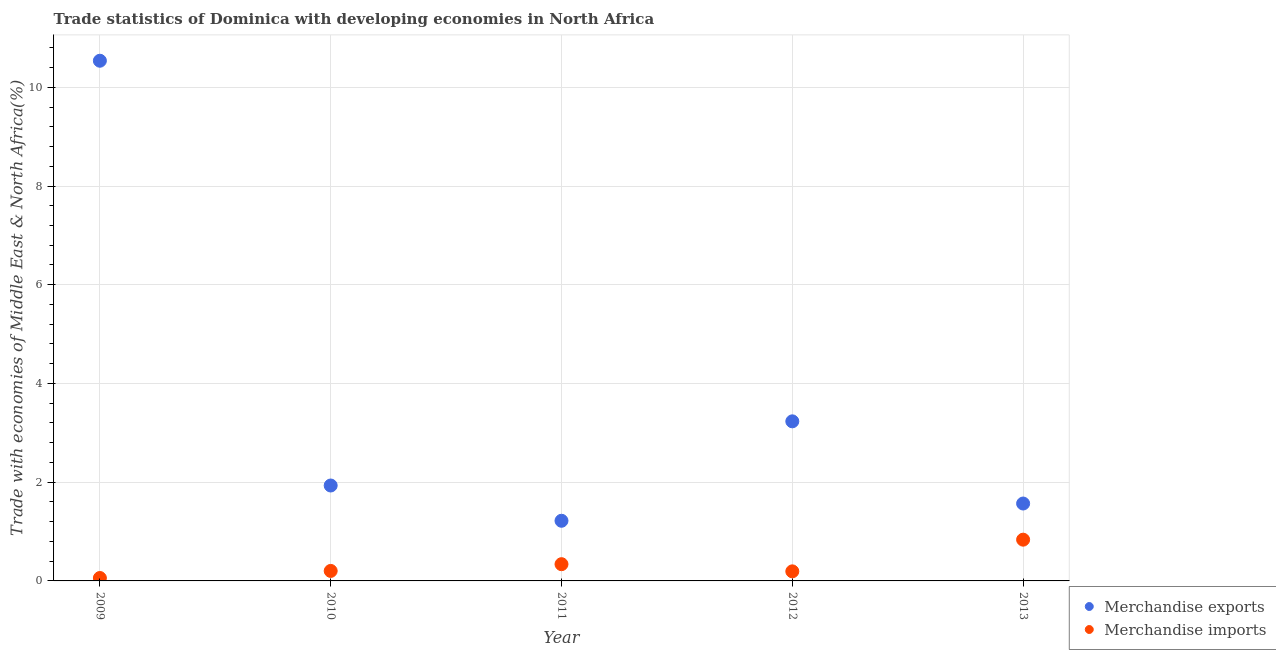What is the merchandise exports in 2012?
Give a very brief answer. 3.23. Across all years, what is the maximum merchandise imports?
Ensure brevity in your answer.  0.84. Across all years, what is the minimum merchandise imports?
Your answer should be very brief. 0.06. In which year was the merchandise imports maximum?
Offer a very short reply. 2013. What is the total merchandise exports in the graph?
Keep it short and to the point. 18.49. What is the difference between the merchandise exports in 2009 and that in 2011?
Give a very brief answer. 9.32. What is the difference between the merchandise exports in 2011 and the merchandise imports in 2013?
Your answer should be very brief. 0.38. What is the average merchandise exports per year?
Make the answer very short. 3.7. In the year 2011, what is the difference between the merchandise exports and merchandise imports?
Your answer should be compact. 0.88. In how many years, is the merchandise exports greater than 6.4 %?
Give a very brief answer. 1. What is the ratio of the merchandise imports in 2011 to that in 2013?
Your response must be concise. 0.41. Is the difference between the merchandise imports in 2010 and 2011 greater than the difference between the merchandise exports in 2010 and 2011?
Make the answer very short. No. What is the difference between the highest and the second highest merchandise imports?
Your answer should be very brief. 0.5. What is the difference between the highest and the lowest merchandise exports?
Provide a succinct answer. 9.32. Is the sum of the merchandise imports in 2010 and 2012 greater than the maximum merchandise exports across all years?
Offer a very short reply. No. Does the merchandise imports monotonically increase over the years?
Offer a very short reply. No. Is the merchandise imports strictly greater than the merchandise exports over the years?
Keep it short and to the point. No. Is the merchandise imports strictly less than the merchandise exports over the years?
Provide a succinct answer. Yes. How many dotlines are there?
Make the answer very short. 2. How many years are there in the graph?
Provide a succinct answer. 5. What is the difference between two consecutive major ticks on the Y-axis?
Your answer should be very brief. 2. Does the graph contain any zero values?
Your answer should be very brief. No. Does the graph contain grids?
Give a very brief answer. Yes. How many legend labels are there?
Offer a terse response. 2. How are the legend labels stacked?
Offer a very short reply. Vertical. What is the title of the graph?
Offer a very short reply. Trade statistics of Dominica with developing economies in North Africa. Does "Automatic Teller Machines" appear as one of the legend labels in the graph?
Offer a terse response. No. What is the label or title of the Y-axis?
Offer a terse response. Trade with economies of Middle East & North Africa(%). What is the Trade with economies of Middle East & North Africa(%) in Merchandise exports in 2009?
Give a very brief answer. 10.54. What is the Trade with economies of Middle East & North Africa(%) in Merchandise imports in 2009?
Provide a short and direct response. 0.06. What is the Trade with economies of Middle East & North Africa(%) in Merchandise exports in 2010?
Your answer should be compact. 1.93. What is the Trade with economies of Middle East & North Africa(%) of Merchandise imports in 2010?
Provide a succinct answer. 0.2. What is the Trade with economies of Middle East & North Africa(%) in Merchandise exports in 2011?
Offer a very short reply. 1.22. What is the Trade with economies of Middle East & North Africa(%) of Merchandise imports in 2011?
Your response must be concise. 0.34. What is the Trade with economies of Middle East & North Africa(%) in Merchandise exports in 2012?
Make the answer very short. 3.23. What is the Trade with economies of Middle East & North Africa(%) of Merchandise imports in 2012?
Your response must be concise. 0.19. What is the Trade with economies of Middle East & North Africa(%) in Merchandise exports in 2013?
Your answer should be very brief. 1.57. What is the Trade with economies of Middle East & North Africa(%) of Merchandise imports in 2013?
Keep it short and to the point. 0.84. Across all years, what is the maximum Trade with economies of Middle East & North Africa(%) in Merchandise exports?
Your response must be concise. 10.54. Across all years, what is the maximum Trade with economies of Middle East & North Africa(%) in Merchandise imports?
Your response must be concise. 0.84. Across all years, what is the minimum Trade with economies of Middle East & North Africa(%) in Merchandise exports?
Your response must be concise. 1.22. Across all years, what is the minimum Trade with economies of Middle East & North Africa(%) in Merchandise imports?
Your answer should be compact. 0.06. What is the total Trade with economies of Middle East & North Africa(%) of Merchandise exports in the graph?
Offer a very short reply. 18.49. What is the total Trade with economies of Middle East & North Africa(%) in Merchandise imports in the graph?
Offer a terse response. 1.63. What is the difference between the Trade with economies of Middle East & North Africa(%) of Merchandise exports in 2009 and that in 2010?
Your response must be concise. 8.61. What is the difference between the Trade with economies of Middle East & North Africa(%) of Merchandise imports in 2009 and that in 2010?
Ensure brevity in your answer.  -0.14. What is the difference between the Trade with economies of Middle East & North Africa(%) in Merchandise exports in 2009 and that in 2011?
Provide a succinct answer. 9.32. What is the difference between the Trade with economies of Middle East & North Africa(%) of Merchandise imports in 2009 and that in 2011?
Your answer should be compact. -0.28. What is the difference between the Trade with economies of Middle East & North Africa(%) in Merchandise exports in 2009 and that in 2012?
Give a very brief answer. 7.3. What is the difference between the Trade with economies of Middle East & North Africa(%) of Merchandise imports in 2009 and that in 2012?
Offer a terse response. -0.13. What is the difference between the Trade with economies of Middle East & North Africa(%) in Merchandise exports in 2009 and that in 2013?
Your response must be concise. 8.97. What is the difference between the Trade with economies of Middle East & North Africa(%) of Merchandise imports in 2009 and that in 2013?
Offer a terse response. -0.78. What is the difference between the Trade with economies of Middle East & North Africa(%) of Merchandise exports in 2010 and that in 2011?
Provide a short and direct response. 0.71. What is the difference between the Trade with economies of Middle East & North Africa(%) of Merchandise imports in 2010 and that in 2011?
Ensure brevity in your answer.  -0.14. What is the difference between the Trade with economies of Middle East & North Africa(%) in Merchandise exports in 2010 and that in 2012?
Provide a succinct answer. -1.3. What is the difference between the Trade with economies of Middle East & North Africa(%) of Merchandise imports in 2010 and that in 2012?
Offer a very short reply. 0.01. What is the difference between the Trade with economies of Middle East & North Africa(%) in Merchandise exports in 2010 and that in 2013?
Offer a very short reply. 0.36. What is the difference between the Trade with economies of Middle East & North Africa(%) in Merchandise imports in 2010 and that in 2013?
Your answer should be compact. -0.63. What is the difference between the Trade with economies of Middle East & North Africa(%) in Merchandise exports in 2011 and that in 2012?
Provide a succinct answer. -2.01. What is the difference between the Trade with economies of Middle East & North Africa(%) of Merchandise imports in 2011 and that in 2012?
Give a very brief answer. 0.15. What is the difference between the Trade with economies of Middle East & North Africa(%) in Merchandise exports in 2011 and that in 2013?
Give a very brief answer. -0.35. What is the difference between the Trade with economies of Middle East & North Africa(%) in Merchandise imports in 2011 and that in 2013?
Offer a terse response. -0.5. What is the difference between the Trade with economies of Middle East & North Africa(%) in Merchandise exports in 2012 and that in 2013?
Keep it short and to the point. 1.66. What is the difference between the Trade with economies of Middle East & North Africa(%) of Merchandise imports in 2012 and that in 2013?
Ensure brevity in your answer.  -0.64. What is the difference between the Trade with economies of Middle East & North Africa(%) in Merchandise exports in 2009 and the Trade with economies of Middle East & North Africa(%) in Merchandise imports in 2010?
Your response must be concise. 10.34. What is the difference between the Trade with economies of Middle East & North Africa(%) of Merchandise exports in 2009 and the Trade with economies of Middle East & North Africa(%) of Merchandise imports in 2011?
Offer a very short reply. 10.2. What is the difference between the Trade with economies of Middle East & North Africa(%) of Merchandise exports in 2009 and the Trade with economies of Middle East & North Africa(%) of Merchandise imports in 2012?
Give a very brief answer. 10.34. What is the difference between the Trade with economies of Middle East & North Africa(%) of Merchandise exports in 2009 and the Trade with economies of Middle East & North Africa(%) of Merchandise imports in 2013?
Offer a very short reply. 9.7. What is the difference between the Trade with economies of Middle East & North Africa(%) of Merchandise exports in 2010 and the Trade with economies of Middle East & North Africa(%) of Merchandise imports in 2011?
Your answer should be compact. 1.59. What is the difference between the Trade with economies of Middle East & North Africa(%) in Merchandise exports in 2010 and the Trade with economies of Middle East & North Africa(%) in Merchandise imports in 2012?
Offer a terse response. 1.74. What is the difference between the Trade with economies of Middle East & North Africa(%) in Merchandise exports in 2010 and the Trade with economies of Middle East & North Africa(%) in Merchandise imports in 2013?
Give a very brief answer. 1.1. What is the difference between the Trade with economies of Middle East & North Africa(%) in Merchandise exports in 2011 and the Trade with economies of Middle East & North Africa(%) in Merchandise imports in 2012?
Offer a terse response. 1.02. What is the difference between the Trade with economies of Middle East & North Africa(%) of Merchandise exports in 2011 and the Trade with economies of Middle East & North Africa(%) of Merchandise imports in 2013?
Your answer should be very brief. 0.38. What is the difference between the Trade with economies of Middle East & North Africa(%) of Merchandise exports in 2012 and the Trade with economies of Middle East & North Africa(%) of Merchandise imports in 2013?
Your answer should be compact. 2.4. What is the average Trade with economies of Middle East & North Africa(%) in Merchandise exports per year?
Make the answer very short. 3.7. What is the average Trade with economies of Middle East & North Africa(%) in Merchandise imports per year?
Make the answer very short. 0.33. In the year 2009, what is the difference between the Trade with economies of Middle East & North Africa(%) in Merchandise exports and Trade with economies of Middle East & North Africa(%) in Merchandise imports?
Keep it short and to the point. 10.48. In the year 2010, what is the difference between the Trade with economies of Middle East & North Africa(%) of Merchandise exports and Trade with economies of Middle East & North Africa(%) of Merchandise imports?
Your answer should be compact. 1.73. In the year 2011, what is the difference between the Trade with economies of Middle East & North Africa(%) in Merchandise exports and Trade with economies of Middle East & North Africa(%) in Merchandise imports?
Provide a succinct answer. 0.88. In the year 2012, what is the difference between the Trade with economies of Middle East & North Africa(%) of Merchandise exports and Trade with economies of Middle East & North Africa(%) of Merchandise imports?
Provide a succinct answer. 3.04. In the year 2013, what is the difference between the Trade with economies of Middle East & North Africa(%) in Merchandise exports and Trade with economies of Middle East & North Africa(%) in Merchandise imports?
Make the answer very short. 0.73. What is the ratio of the Trade with economies of Middle East & North Africa(%) in Merchandise exports in 2009 to that in 2010?
Offer a terse response. 5.45. What is the ratio of the Trade with economies of Middle East & North Africa(%) in Merchandise imports in 2009 to that in 2010?
Offer a very short reply. 0.29. What is the ratio of the Trade with economies of Middle East & North Africa(%) in Merchandise exports in 2009 to that in 2011?
Offer a terse response. 8.65. What is the ratio of the Trade with economies of Middle East & North Africa(%) in Merchandise imports in 2009 to that in 2011?
Your answer should be very brief. 0.17. What is the ratio of the Trade with economies of Middle East & North Africa(%) in Merchandise exports in 2009 to that in 2012?
Your answer should be very brief. 3.26. What is the ratio of the Trade with economies of Middle East & North Africa(%) of Merchandise imports in 2009 to that in 2012?
Offer a terse response. 0.3. What is the ratio of the Trade with economies of Middle East & North Africa(%) in Merchandise exports in 2009 to that in 2013?
Your answer should be very brief. 6.72. What is the ratio of the Trade with economies of Middle East & North Africa(%) in Merchandise imports in 2009 to that in 2013?
Provide a succinct answer. 0.07. What is the ratio of the Trade with economies of Middle East & North Africa(%) in Merchandise exports in 2010 to that in 2011?
Ensure brevity in your answer.  1.59. What is the ratio of the Trade with economies of Middle East & North Africa(%) in Merchandise imports in 2010 to that in 2011?
Your answer should be very brief. 0.6. What is the ratio of the Trade with economies of Middle East & North Africa(%) of Merchandise exports in 2010 to that in 2012?
Offer a very short reply. 0.6. What is the ratio of the Trade with economies of Middle East & North Africa(%) in Merchandise imports in 2010 to that in 2012?
Provide a short and direct response. 1.05. What is the ratio of the Trade with economies of Middle East & North Africa(%) in Merchandise exports in 2010 to that in 2013?
Ensure brevity in your answer.  1.23. What is the ratio of the Trade with economies of Middle East & North Africa(%) of Merchandise imports in 2010 to that in 2013?
Your answer should be very brief. 0.24. What is the ratio of the Trade with economies of Middle East & North Africa(%) in Merchandise exports in 2011 to that in 2012?
Provide a short and direct response. 0.38. What is the ratio of the Trade with economies of Middle East & North Africa(%) in Merchandise imports in 2011 to that in 2012?
Your answer should be compact. 1.75. What is the ratio of the Trade with economies of Middle East & North Africa(%) of Merchandise exports in 2011 to that in 2013?
Your answer should be very brief. 0.78. What is the ratio of the Trade with economies of Middle East & North Africa(%) of Merchandise imports in 2011 to that in 2013?
Offer a very short reply. 0.41. What is the ratio of the Trade with economies of Middle East & North Africa(%) of Merchandise exports in 2012 to that in 2013?
Your response must be concise. 2.06. What is the ratio of the Trade with economies of Middle East & North Africa(%) in Merchandise imports in 2012 to that in 2013?
Offer a terse response. 0.23. What is the difference between the highest and the second highest Trade with economies of Middle East & North Africa(%) in Merchandise exports?
Give a very brief answer. 7.3. What is the difference between the highest and the second highest Trade with economies of Middle East & North Africa(%) of Merchandise imports?
Give a very brief answer. 0.5. What is the difference between the highest and the lowest Trade with economies of Middle East & North Africa(%) in Merchandise exports?
Make the answer very short. 9.32. What is the difference between the highest and the lowest Trade with economies of Middle East & North Africa(%) of Merchandise imports?
Offer a terse response. 0.78. 